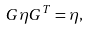Convert formula to latex. <formula><loc_0><loc_0><loc_500><loc_500>G \eta G ^ { T } = \eta ,</formula> 